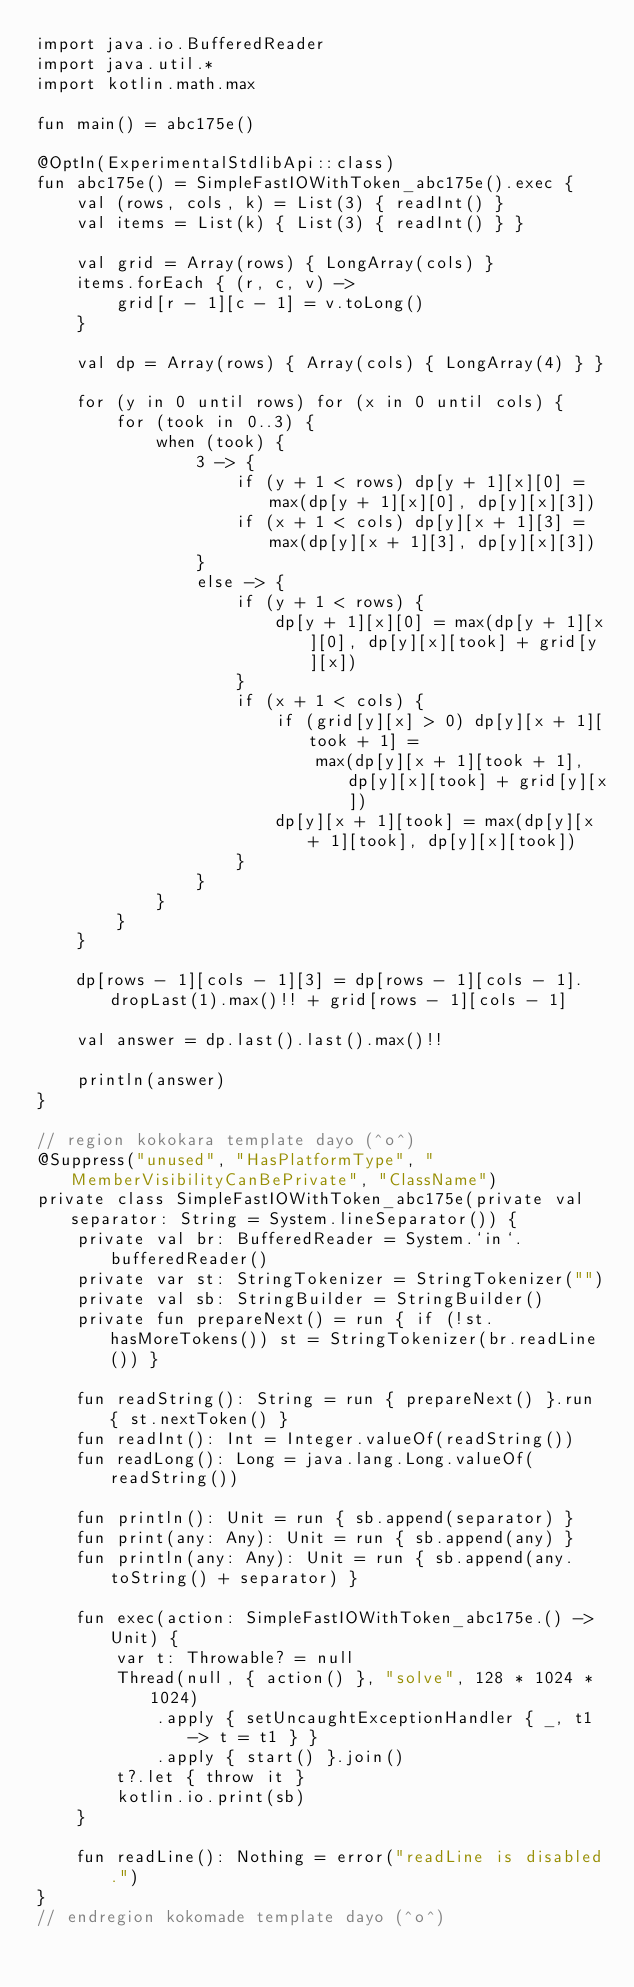<code> <loc_0><loc_0><loc_500><loc_500><_Kotlin_>import java.io.BufferedReader
import java.util.*
import kotlin.math.max

fun main() = abc175e()

@OptIn(ExperimentalStdlibApi::class)
fun abc175e() = SimpleFastIOWithToken_abc175e().exec {
    val (rows, cols, k) = List(3) { readInt() }
    val items = List(k) { List(3) { readInt() } }

    val grid = Array(rows) { LongArray(cols) }
    items.forEach { (r, c, v) ->
        grid[r - 1][c - 1] = v.toLong()
    }

    val dp = Array(rows) { Array(cols) { LongArray(4) } }

    for (y in 0 until rows) for (x in 0 until cols) {
        for (took in 0..3) {
            when (took) {
                3 -> {
                    if (y + 1 < rows) dp[y + 1][x][0] = max(dp[y + 1][x][0], dp[y][x][3])
                    if (x + 1 < cols) dp[y][x + 1][3] = max(dp[y][x + 1][3], dp[y][x][3])
                }
                else -> {
                    if (y + 1 < rows) {
                        dp[y + 1][x][0] = max(dp[y + 1][x][0], dp[y][x][took] + grid[y][x])
                    }
                    if (x + 1 < cols) {
                        if (grid[y][x] > 0) dp[y][x + 1][took + 1] =
                            max(dp[y][x + 1][took + 1], dp[y][x][took] + grid[y][x])
                        dp[y][x + 1][took] = max(dp[y][x + 1][took], dp[y][x][took])
                    }
                }
            }
        }
    }

    dp[rows - 1][cols - 1][3] = dp[rows - 1][cols - 1].dropLast(1).max()!! + grid[rows - 1][cols - 1]

    val answer = dp.last().last().max()!!

    println(answer)
}

// region kokokara template dayo (^o^)
@Suppress("unused", "HasPlatformType", "MemberVisibilityCanBePrivate", "ClassName")
private class SimpleFastIOWithToken_abc175e(private val separator: String = System.lineSeparator()) {
    private val br: BufferedReader = System.`in`.bufferedReader()
    private var st: StringTokenizer = StringTokenizer("")
    private val sb: StringBuilder = StringBuilder()
    private fun prepareNext() = run { if (!st.hasMoreTokens()) st = StringTokenizer(br.readLine()) }

    fun readString(): String = run { prepareNext() }.run { st.nextToken() }
    fun readInt(): Int = Integer.valueOf(readString())
    fun readLong(): Long = java.lang.Long.valueOf(readString())

    fun println(): Unit = run { sb.append(separator) }
    fun print(any: Any): Unit = run { sb.append(any) }
    fun println(any: Any): Unit = run { sb.append(any.toString() + separator) }

    fun exec(action: SimpleFastIOWithToken_abc175e.() -> Unit) {
        var t: Throwable? = null
        Thread(null, { action() }, "solve", 128 * 1024 * 1024)
            .apply { setUncaughtExceptionHandler { _, t1 -> t = t1 } }
            .apply { start() }.join()
        t?.let { throw it }
        kotlin.io.print(sb)
    }

    fun readLine(): Nothing = error("readLine is disabled.")
}
// endregion kokomade template dayo (^o^)
</code> 